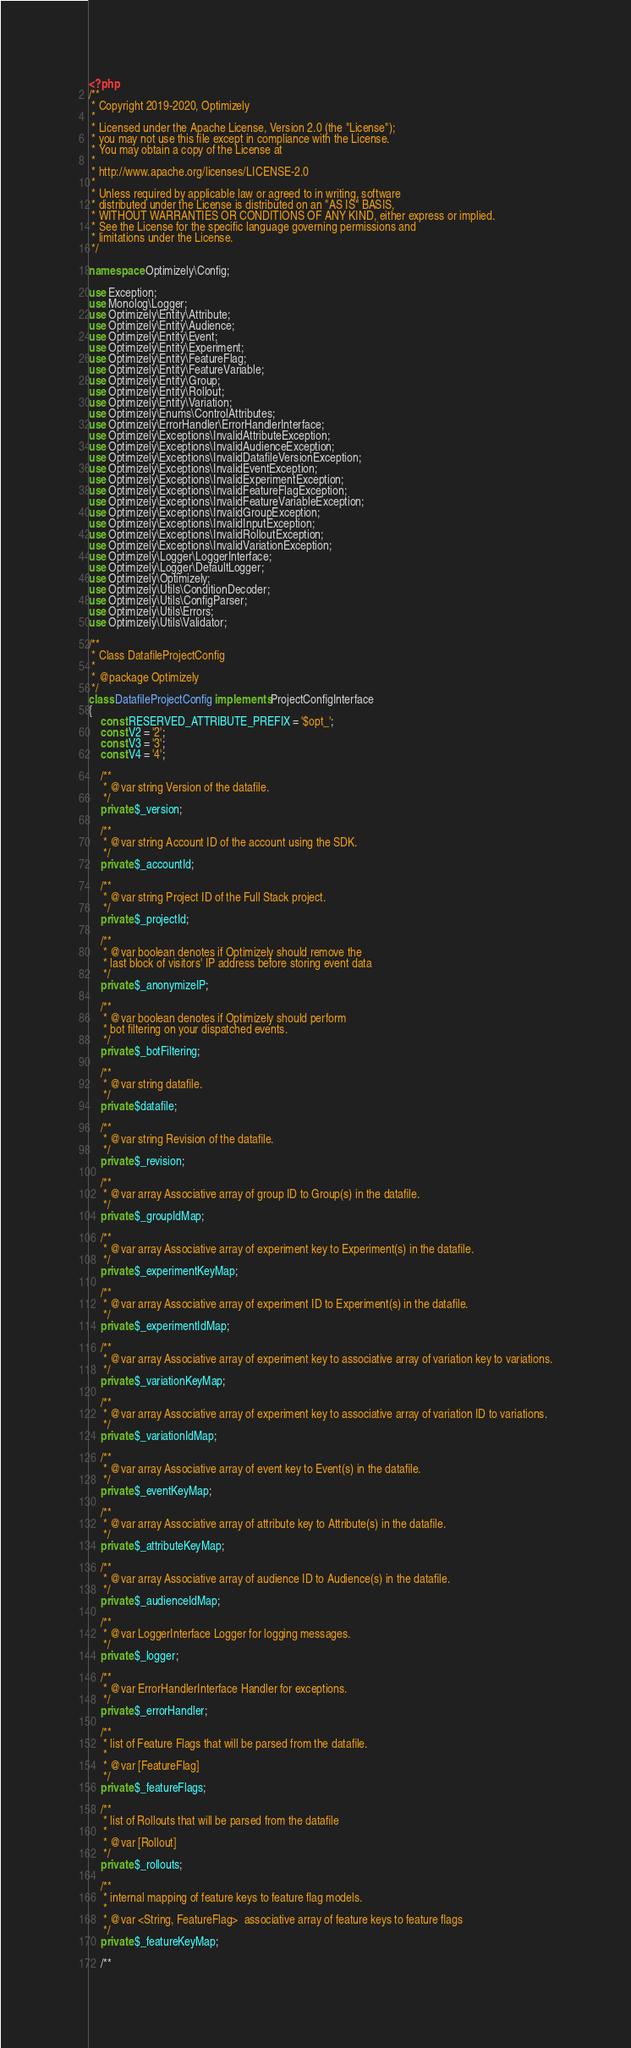<code> <loc_0><loc_0><loc_500><loc_500><_PHP_><?php
/**
 * Copyright 2019-2020, Optimizely
 *
 * Licensed under the Apache License, Version 2.0 (the "License");
 * you may not use this file except in compliance with the License.
 * You may obtain a copy of the License at
 *
 * http://www.apache.org/licenses/LICENSE-2.0
 *
 * Unless required by applicable law or agreed to in writing, software
 * distributed under the License is distributed on an "AS IS" BASIS,
 * WITHOUT WARRANTIES OR CONDITIONS OF ANY KIND, either express or implied.
 * See the License for the specific language governing permissions and
 * limitations under the License.
 */

namespace Optimizely\Config;

use Exception;
use Monolog\Logger;
use Optimizely\Entity\Attribute;
use Optimizely\Entity\Audience;
use Optimizely\Entity\Event;
use Optimizely\Entity\Experiment;
use Optimizely\Entity\FeatureFlag;
use Optimizely\Entity\FeatureVariable;
use Optimizely\Entity\Group;
use Optimizely\Entity\Rollout;
use Optimizely\Entity\Variation;
use Optimizely\Enums\ControlAttributes;
use Optimizely\ErrorHandler\ErrorHandlerInterface;
use Optimizely\Exceptions\InvalidAttributeException;
use Optimizely\Exceptions\InvalidAudienceException;
use Optimizely\Exceptions\InvalidDatafileVersionException;
use Optimizely\Exceptions\InvalidEventException;
use Optimizely\Exceptions\InvalidExperimentException;
use Optimizely\Exceptions\InvalidFeatureFlagException;
use Optimizely\Exceptions\InvalidFeatureVariableException;
use Optimizely\Exceptions\InvalidGroupException;
use Optimizely\Exceptions\InvalidInputException;
use Optimizely\Exceptions\InvalidRolloutException;
use Optimizely\Exceptions\InvalidVariationException;
use Optimizely\Logger\LoggerInterface;
use Optimizely\Logger\DefaultLogger;
use Optimizely\Optimizely;
use Optimizely\Utils\ConditionDecoder;
use Optimizely\Utils\ConfigParser;
use Optimizely\Utils\Errors;
use Optimizely\Utils\Validator;

/**
 * Class DatafileProjectConfig
 *
 * @package Optimizely
 */
class DatafileProjectConfig implements ProjectConfigInterface
{
    const RESERVED_ATTRIBUTE_PREFIX = '$opt_';
    const V2 = '2';
    const V3 = '3';
    const V4 = '4';

    /**
     * @var string Version of the datafile.
     */
    private $_version;

    /**
     * @var string Account ID of the account using the SDK.
     */
    private $_accountId;

    /**
     * @var string Project ID of the Full Stack project.
     */
    private $_projectId;

    /**
     * @var boolean denotes if Optimizely should remove the
     * last block of visitors' IP address before storing event data
     */
    private $_anonymizeIP;

    /**
     * @var boolean denotes if Optimizely should perform
     * bot filtering on your dispatched events.
     */
    private $_botFiltering;

    /**
     * @var string datafile.
     */
    private $datafile;

    /**
     * @var string Revision of the datafile.
     */
    private $_revision;

    /**
     * @var array Associative array of group ID to Group(s) in the datafile.
     */
    private $_groupIdMap;

    /**
     * @var array Associative array of experiment key to Experiment(s) in the datafile.
     */
    private $_experimentKeyMap;

    /**
     * @var array Associative array of experiment ID to Experiment(s) in the datafile.
     */
    private $_experimentIdMap;

    /**
     * @var array Associative array of experiment key to associative array of variation key to variations.
     */
    private $_variationKeyMap;

    /**
     * @var array Associative array of experiment key to associative array of variation ID to variations.
     */
    private $_variationIdMap;

    /**
     * @var array Associative array of event key to Event(s) in the datafile.
     */
    private $_eventKeyMap;

    /**
     * @var array Associative array of attribute key to Attribute(s) in the datafile.
     */
    private $_attributeKeyMap;

    /**
     * @var array Associative array of audience ID to Audience(s) in the datafile.
     */
    private $_audienceIdMap;

    /**
     * @var LoggerInterface Logger for logging messages.
     */
    private $_logger;

    /**
     * @var ErrorHandlerInterface Handler for exceptions.
     */
    private $_errorHandler;

    /**
     * list of Feature Flags that will be parsed from the datafile.
     *
     * @var [FeatureFlag]
     */
    private $_featureFlags;

    /**
     * list of Rollouts that will be parsed from the datafile
     *
     * @var [Rollout]
     */
    private $_rollouts;

    /**
     * internal mapping of feature keys to feature flag models.
     *
     * @var <String, FeatureFlag>  associative array of feature keys to feature flags
     */
    private $_featureKeyMap;

    /**</code> 